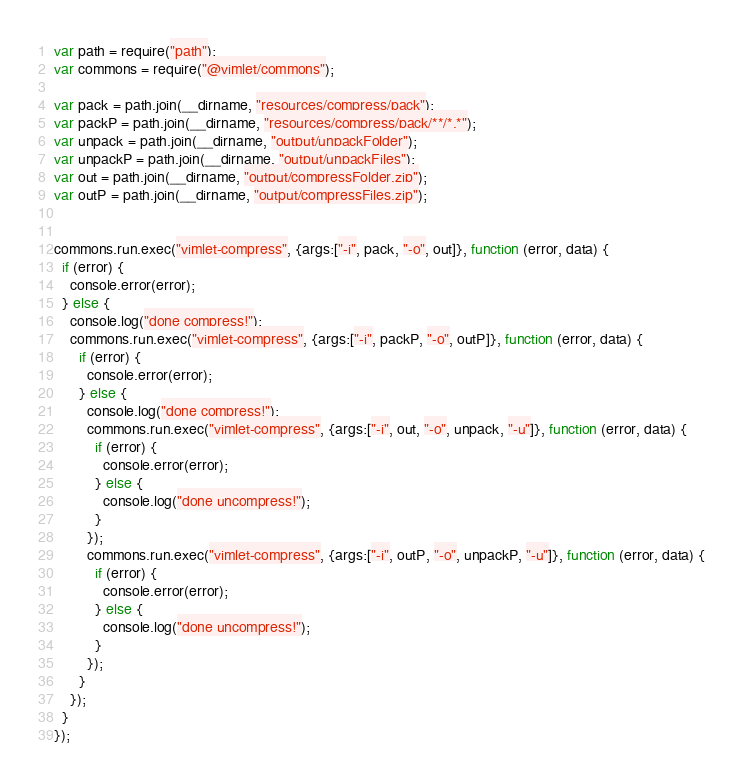Convert code to text. <code><loc_0><loc_0><loc_500><loc_500><_JavaScript_>var path = require("path");
var commons = require("@vimlet/commons");

var pack = path.join(__dirname, "resources/compress/pack");
var packP = path.join(__dirname, "resources/compress/pack/**/*.*");
var unpack = path.join(__dirname, "output/unpackFolder");
var unpackP = path.join(__dirname, "output/unpackFiles");
var out = path.join(__dirname, "output/compressFolder.zip");
var outP = path.join(__dirname, "output/compressFiles.zip");


commons.run.exec("vimlet-compress", {args:["-i", pack, "-o", out]}, function (error, data) {
  if (error) {
    console.error(error);
  } else {
    console.log("done compress!");
    commons.run.exec("vimlet-compress", {args:["-i", packP, "-o", outP]}, function (error, data) {
      if (error) {
        console.error(error);
      } else {
        console.log("done compress!");
        commons.run.exec("vimlet-compress", {args:["-i", out, "-o", unpack, "-u"]}, function (error, data) {
          if (error) {
            console.error(error);
          } else {
            console.log("done uncompress!");
          }
        });  
        commons.run.exec("vimlet-compress", {args:["-i", outP, "-o", unpackP, "-u"]}, function (error, data) {
          if (error) {
            console.error(error);
          } else {
            console.log("done uncompress!");
          }
        });    
      }
    });
  }
});</code> 